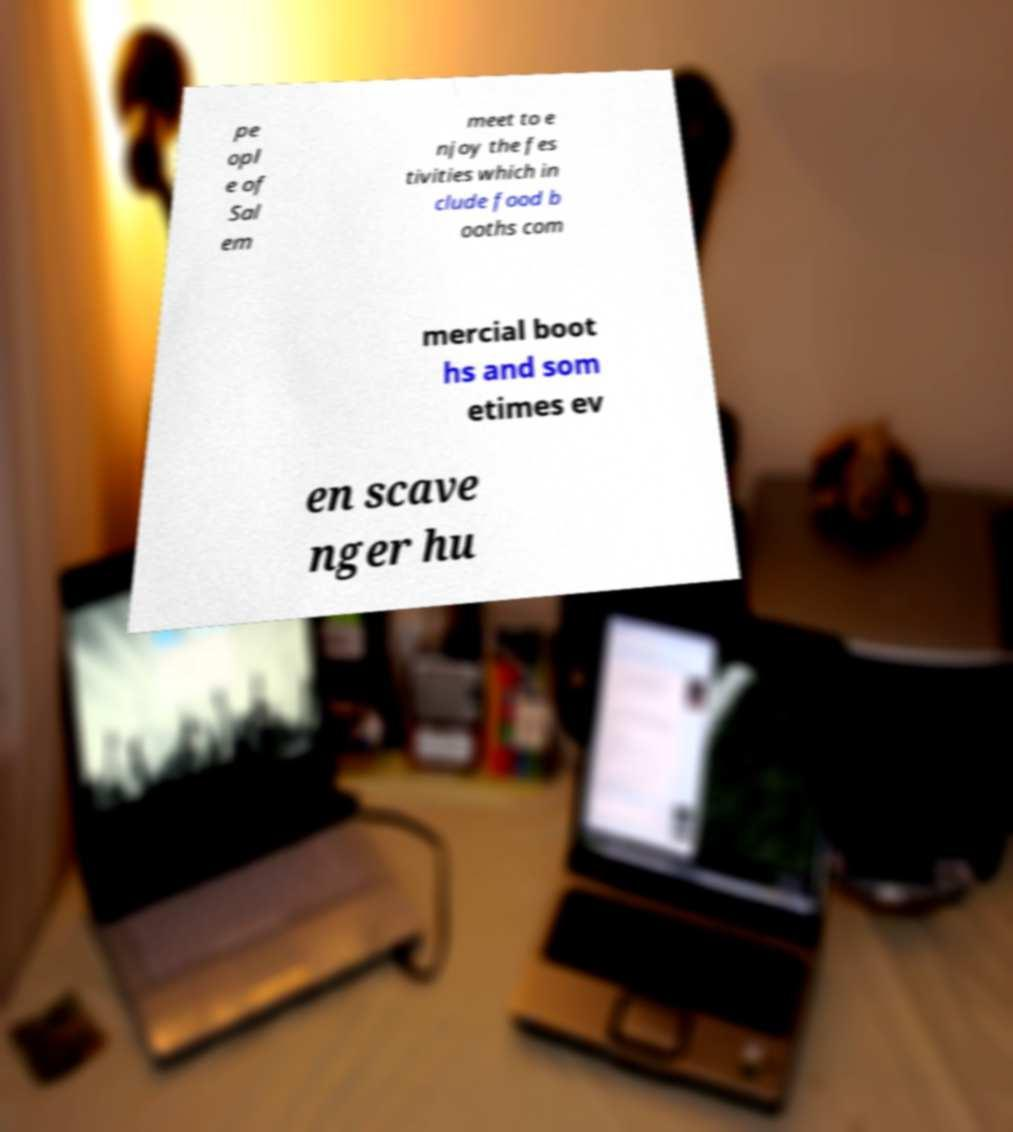Please read and relay the text visible in this image. What does it say? pe opl e of Sal em meet to e njoy the fes tivities which in clude food b ooths com mercial boot hs and som etimes ev en scave nger hu 